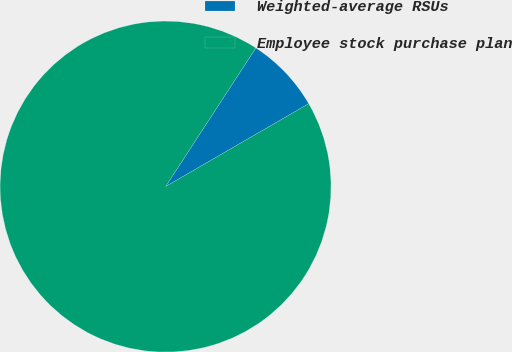Convert chart. <chart><loc_0><loc_0><loc_500><loc_500><pie_chart><fcel>Weighted-average RSUs<fcel>Employee stock purchase plan<nl><fcel>7.46%<fcel>92.54%<nl></chart> 